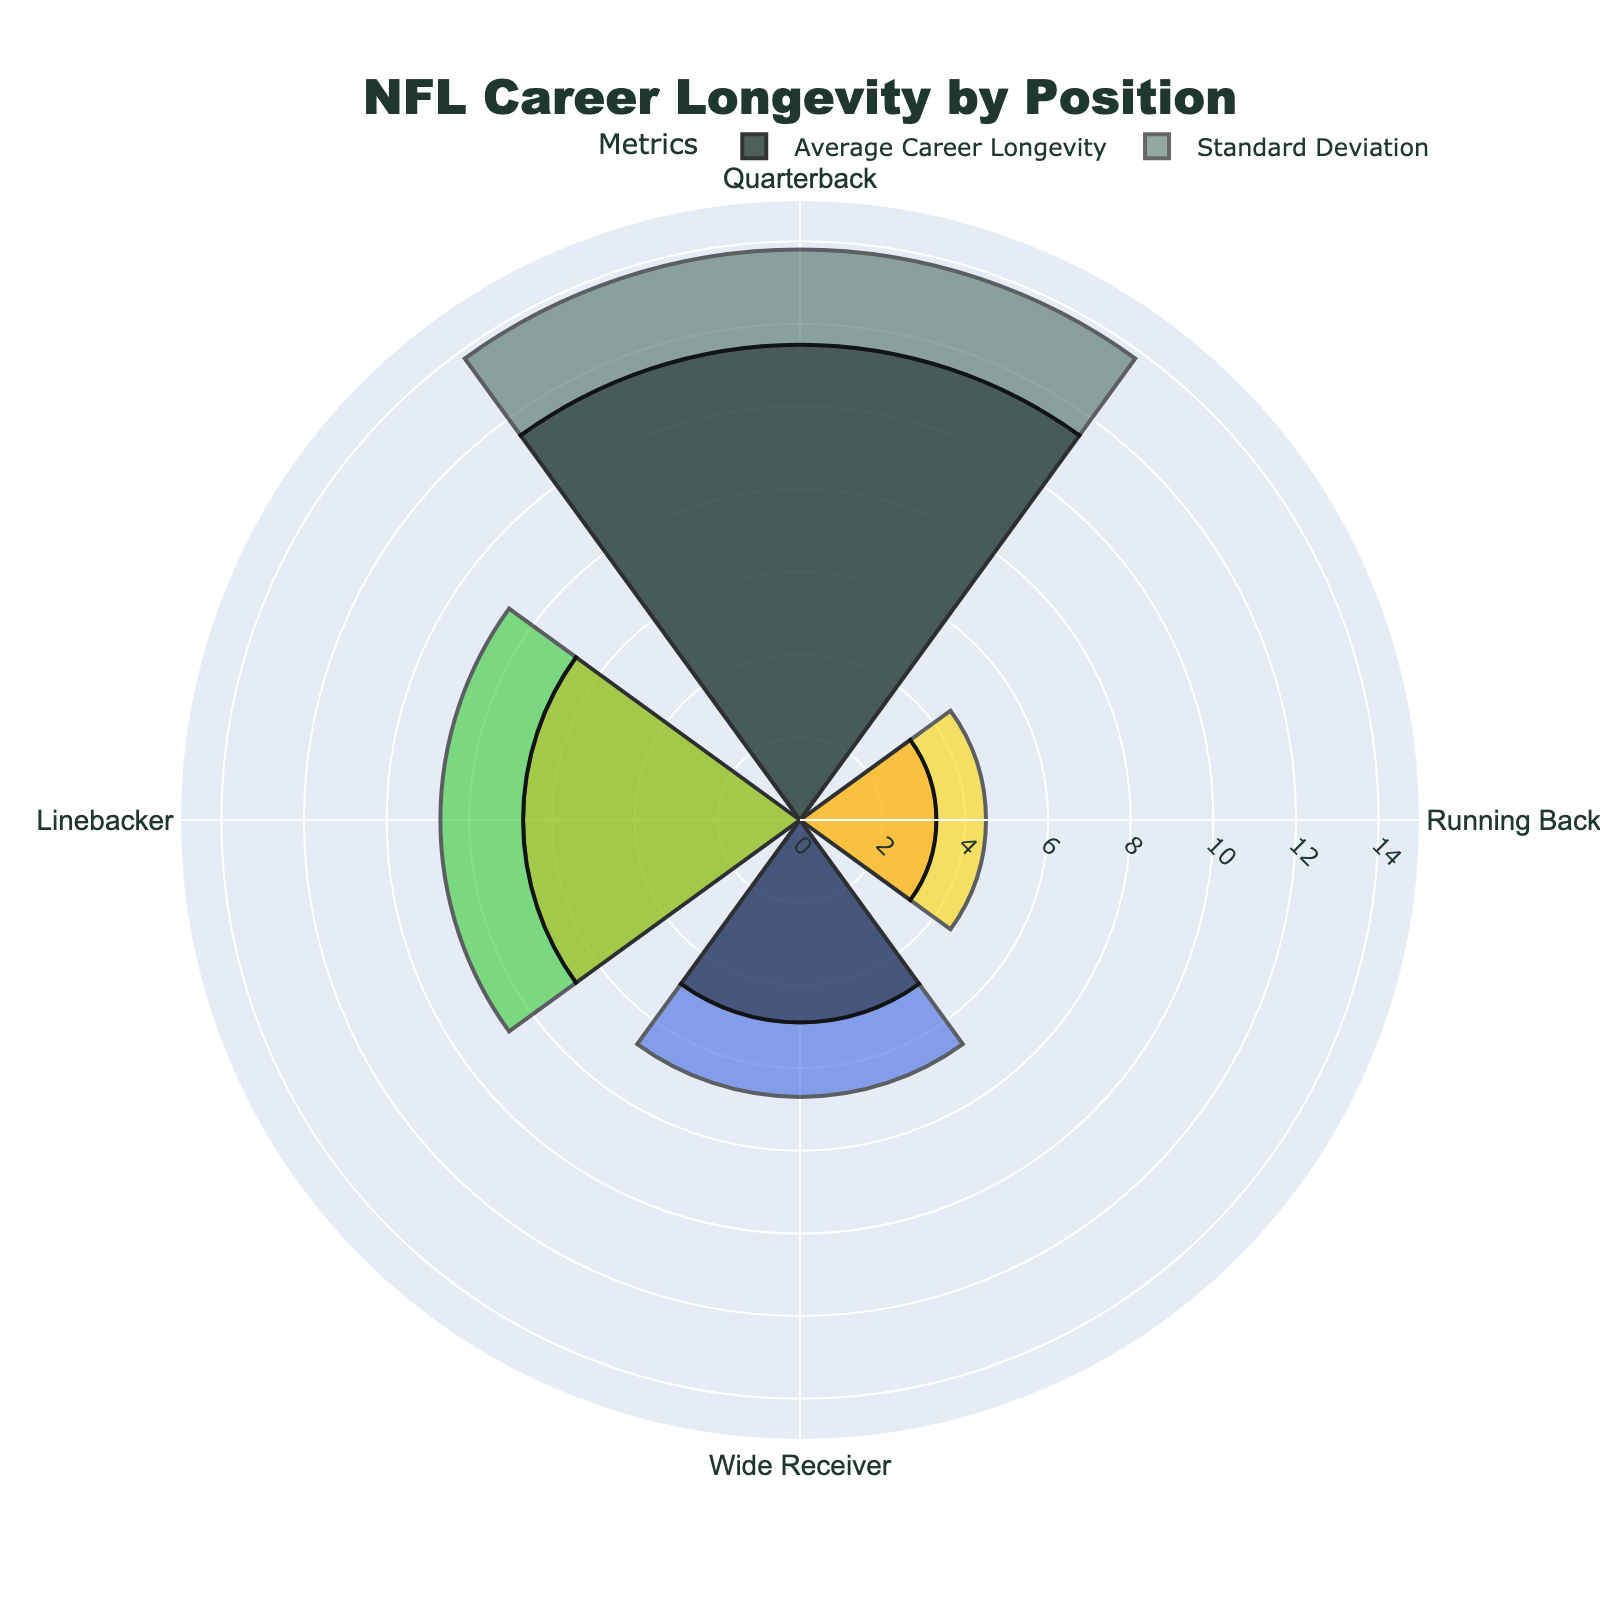What's the title of the figure? The title of the figure is prominently displayed at the top, describing what the chart represents.
Answer: NFL Career Longevity by Position Which position has the highest average career longevity? Looking at the length of the bars in the rose chart, the longest bar represents the highest average career longevity.
Answer: Quarterback How many positions are represented in the chart? By counting the number of different sections or bars in the chart, each corresponding to a position.
Answer: Four Which position has the shortest average career longevity? Identifying the shortest bar in the rose chart will indicate the position with the shortest career longevity.
Answer: Running Back What's the average career longevity for Wide Receivers? By referring to the labels and lengths of the bars in the chart, we can identify the value corresponding to Wide Receiver.
Answer: 4.9 years What is the range of average career longevity values represented in the chart? Subtract the shortest career longevity value from the longest one to find the range. The longest career longevity is 11.5 (Quarterback) and the shortest is 3.3 (Running Back).
Answer: 8.2 years Which position has the highest standard deviation in career longevity? Observing the second set of bars representing the standard deviation in different colors, the highest bar indicates the highest standard deviation.
Answer: Quarterback Compare the standard deviation in career longevity between Wide Receivers and Linebackers. Which one is higher? Looking at the bars for standard deviation, compare the lengths of the bars for Wide Receiver and Linebacker to determine which is larger.
Answer: Linebacker What notable player is associated with the Quarterback position in the chart? The chart provides information about notable players along with each position, so reference the corresponding section.
Answer: Aaron Rodgers How does the average career longevity of Linebackers compare to Running Backs? Looking at the relative lengths of the bars for these two positions, it’s easy to see which one is longer.
Answer: Linebacker is longer 